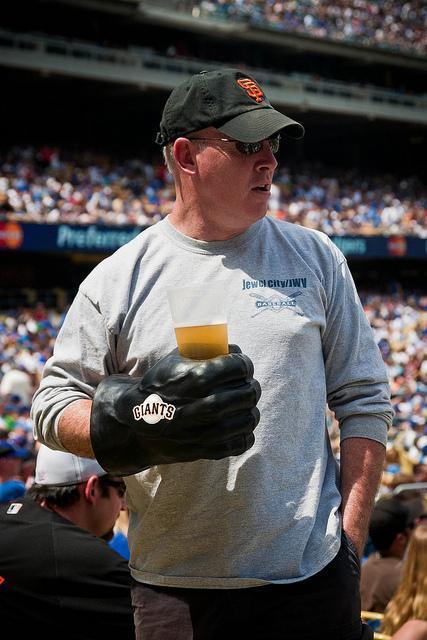How many people can you see?
Give a very brief answer. 4. 